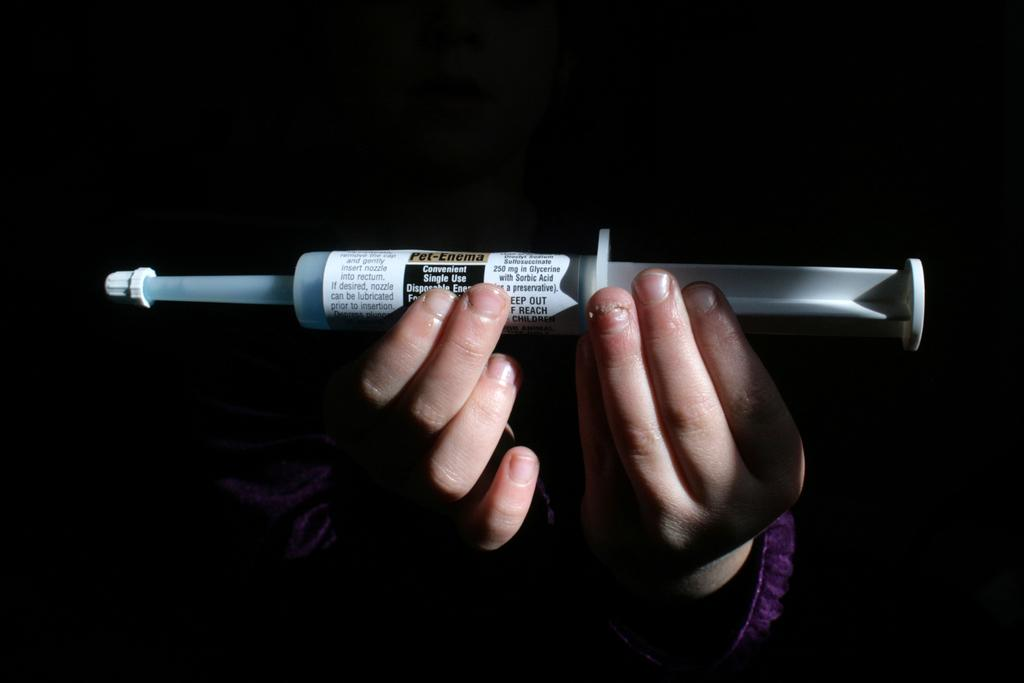What body parts of a person can be seen in the image? A person's hands are visible in the image. What is the person holding in their hands? The person is holding an injection. Can you describe the injection? The injection has text on it. What type of zebra can be seen in the image? There is no zebra present in the image. What idea did the person come up with while holding the injection? The image does not provide any information about the person's thoughts or ideas. 